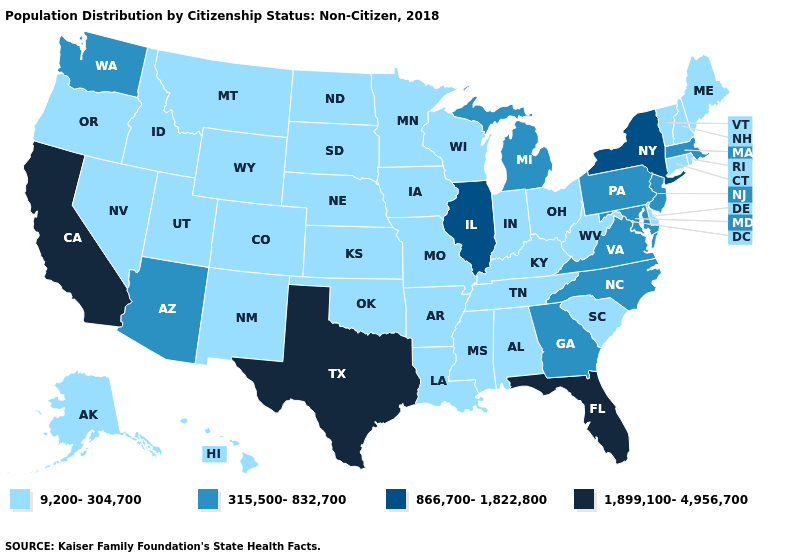What is the highest value in states that border North Carolina?
Answer briefly. 315,500-832,700. Does the map have missing data?
Write a very short answer. No. What is the value of Tennessee?
Concise answer only. 9,200-304,700. Does the map have missing data?
Concise answer only. No. Does the first symbol in the legend represent the smallest category?
Concise answer only. Yes. Name the states that have a value in the range 866,700-1,822,800?
Keep it brief. Illinois, New York. Among the states that border Illinois , which have the highest value?
Be succinct. Indiana, Iowa, Kentucky, Missouri, Wisconsin. Among the states that border Montana , which have the lowest value?
Short answer required. Idaho, North Dakota, South Dakota, Wyoming. How many symbols are there in the legend?
Answer briefly. 4. What is the value of Connecticut?
Short answer required. 9,200-304,700. What is the highest value in the MidWest ?
Give a very brief answer. 866,700-1,822,800. Which states hav the highest value in the West?
Keep it brief. California. Does Delaware have a higher value than New Hampshire?
Be succinct. No. What is the highest value in the USA?
Write a very short answer. 1,899,100-4,956,700. What is the value of New Jersey?
Keep it brief. 315,500-832,700. 